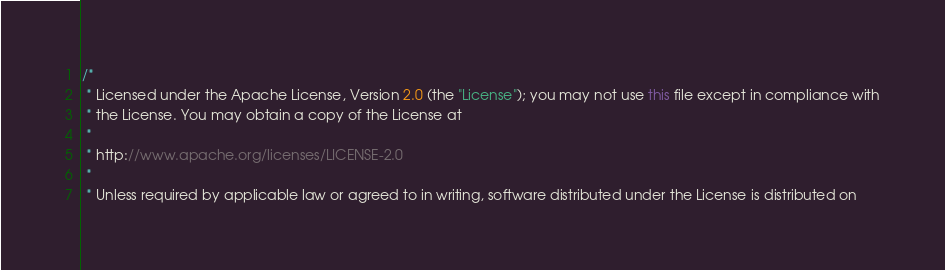<code> <loc_0><loc_0><loc_500><loc_500><_Java_>/*
 * Licensed under the Apache License, Version 2.0 (the "License"); you may not use this file except in compliance with
 * the License. You may obtain a copy of the License at
 *
 * http://www.apache.org/licenses/LICENSE-2.0
 *
 * Unless required by applicable law or agreed to in writing, software distributed under the License is distributed on</code> 